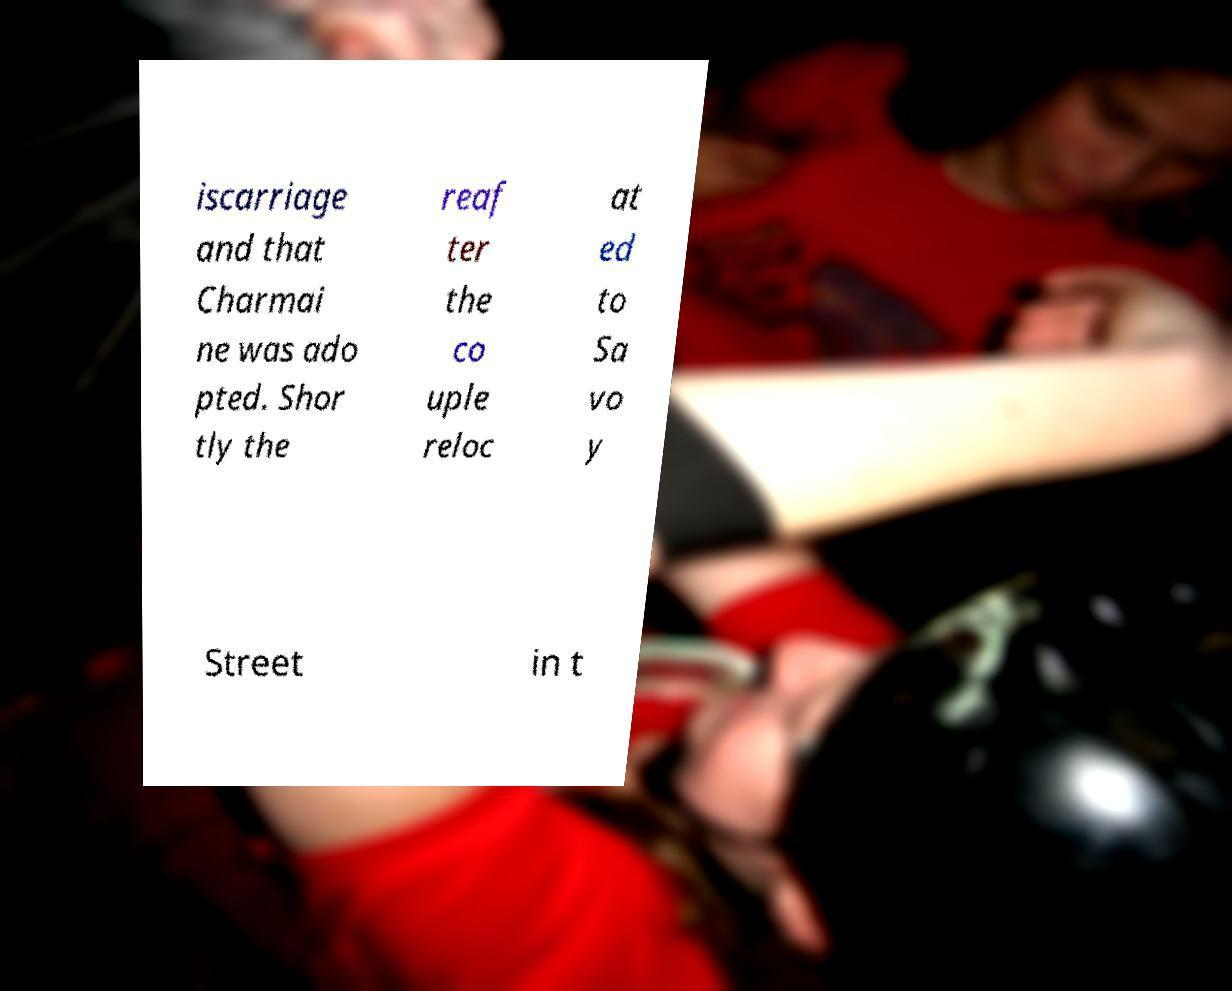I need the written content from this picture converted into text. Can you do that? iscarriage and that Charmai ne was ado pted. Shor tly the reaf ter the co uple reloc at ed to Sa vo y Street in t 